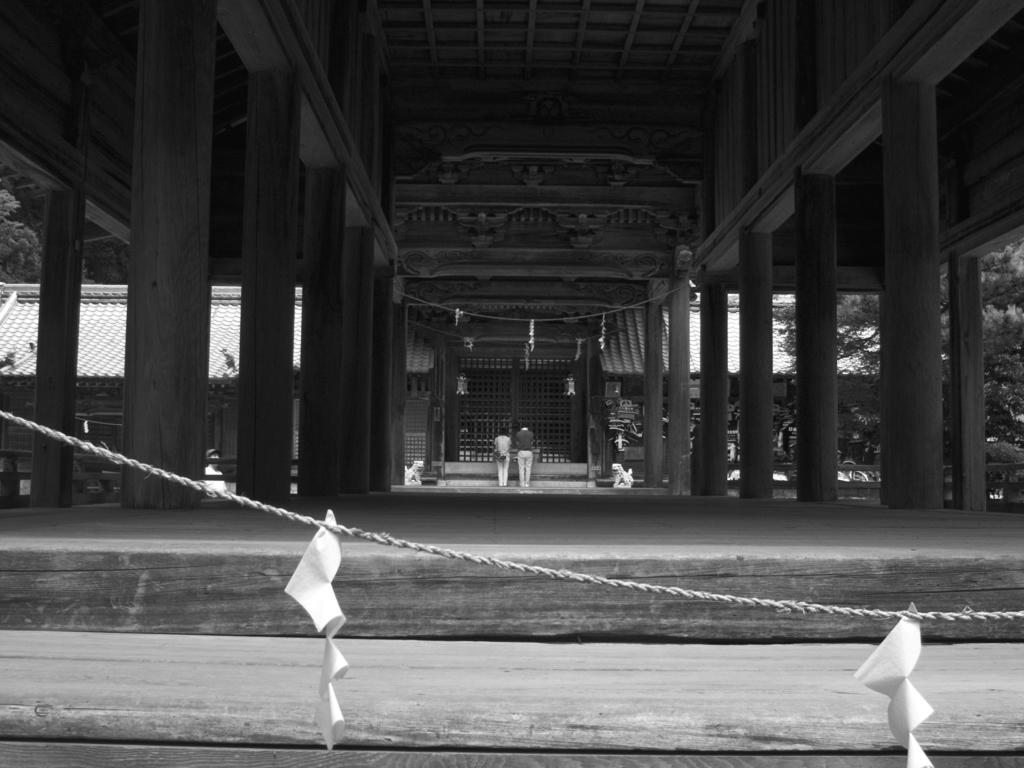What is the color scheme of the image? The image is black and white. What object can be seen hanging in the image? Papers are hung on a rope in the image. What type of structure is visible in the image? There is a building with pillars in the image. What type of vegetation is on the right side of the image? There are trees on the right side of the image. Where is the book located in the image? There is no book present in the image. What type of form is being filled out by the person in the image? There is no person or form present in the image. 